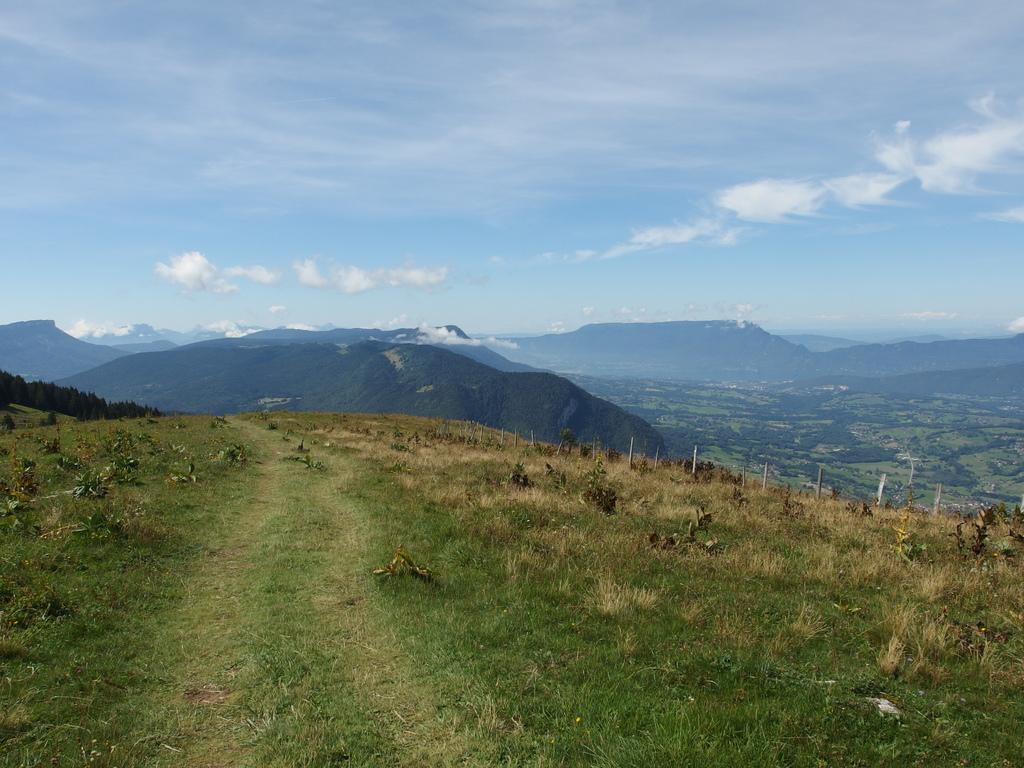What type of vegetation can be seen in the image? There are plants and trees in the image. What type of terrain is visible in the image? There are hills visible in the image. What is the color and condition of the sky in the image? The sky is blue and cloudy in the image. What type of ground cover is present in the image? There is grass on the ground in the image. How many fans are visible in the image? There are no fans present in the image. Are there any dolls interacting with the plants in the image? There are no dolls present in the image. 